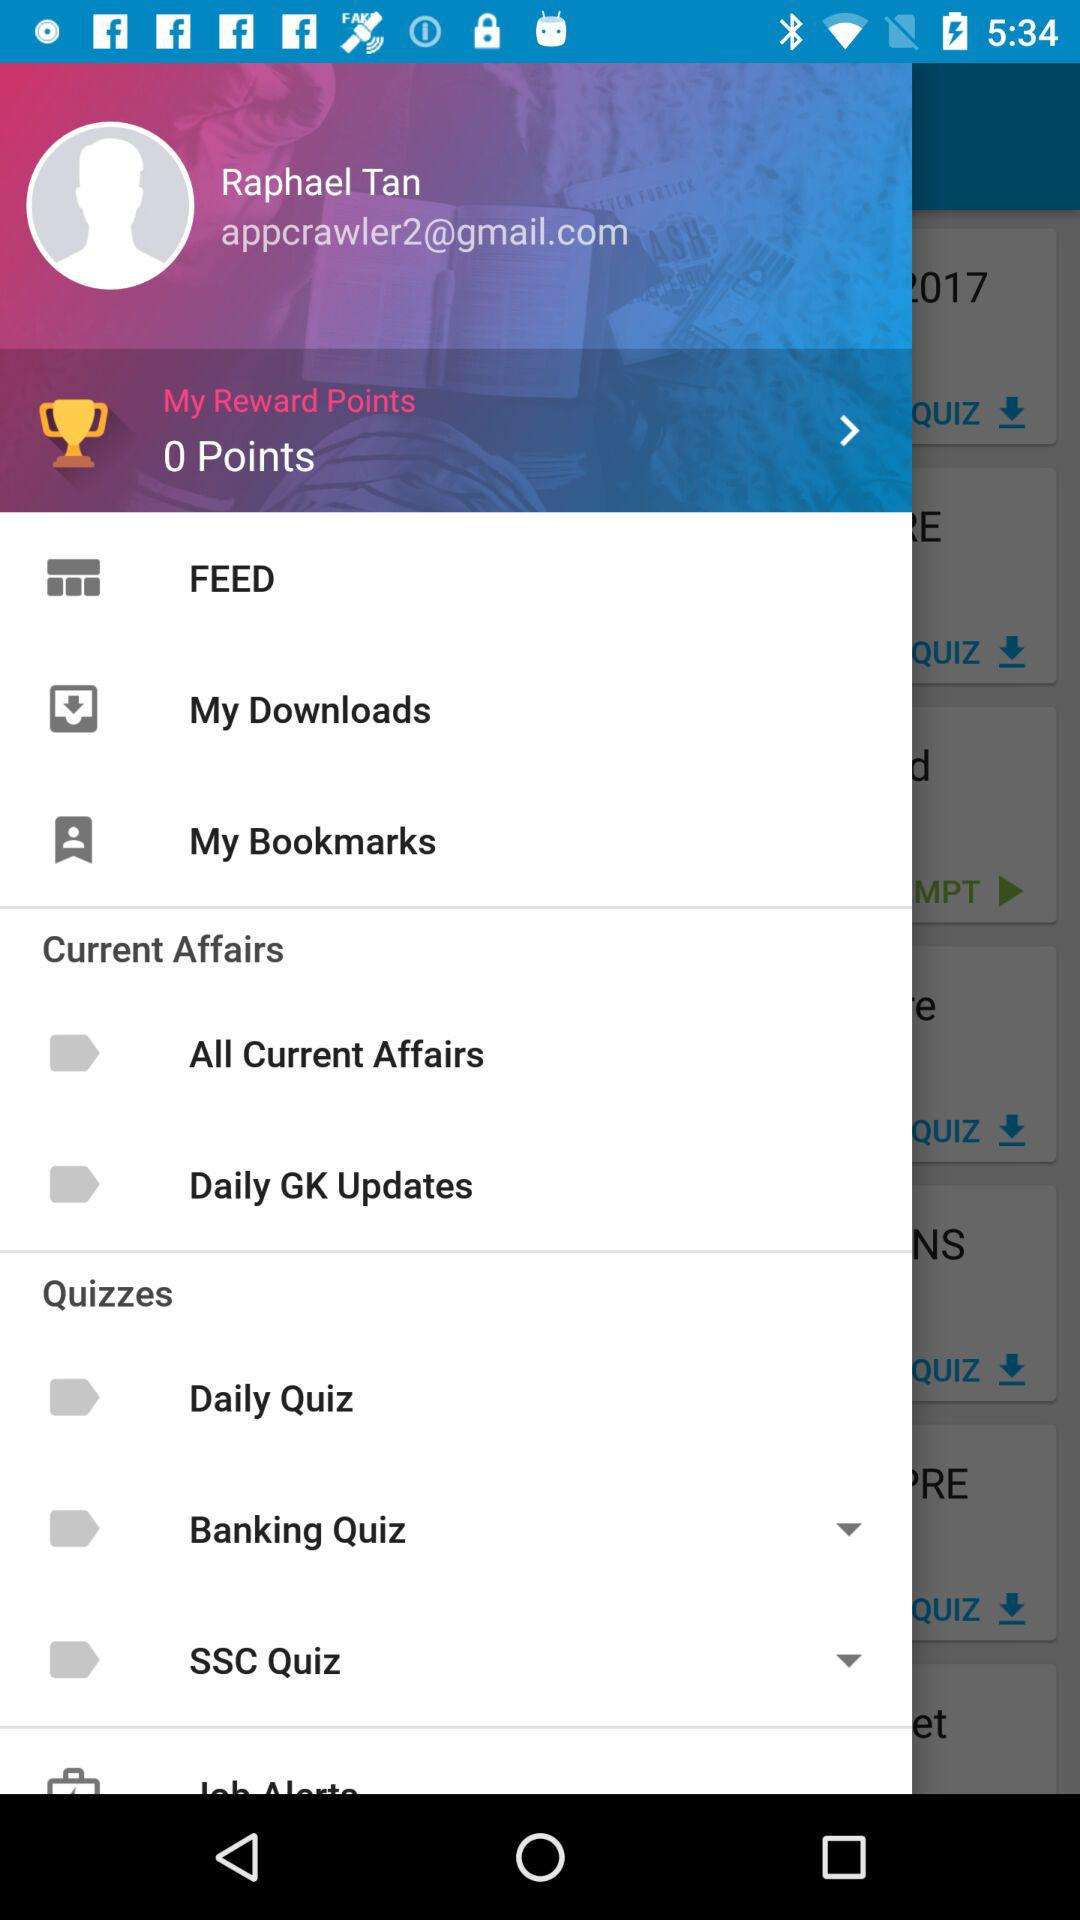What is the name of the user? The name of the user is Raphael Tan. 